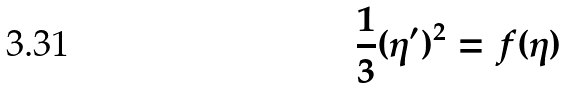Convert formula to latex. <formula><loc_0><loc_0><loc_500><loc_500>\frac { 1 } { 3 } ( \eta ^ { \prime } ) ^ { 2 } = f ( \eta )</formula> 